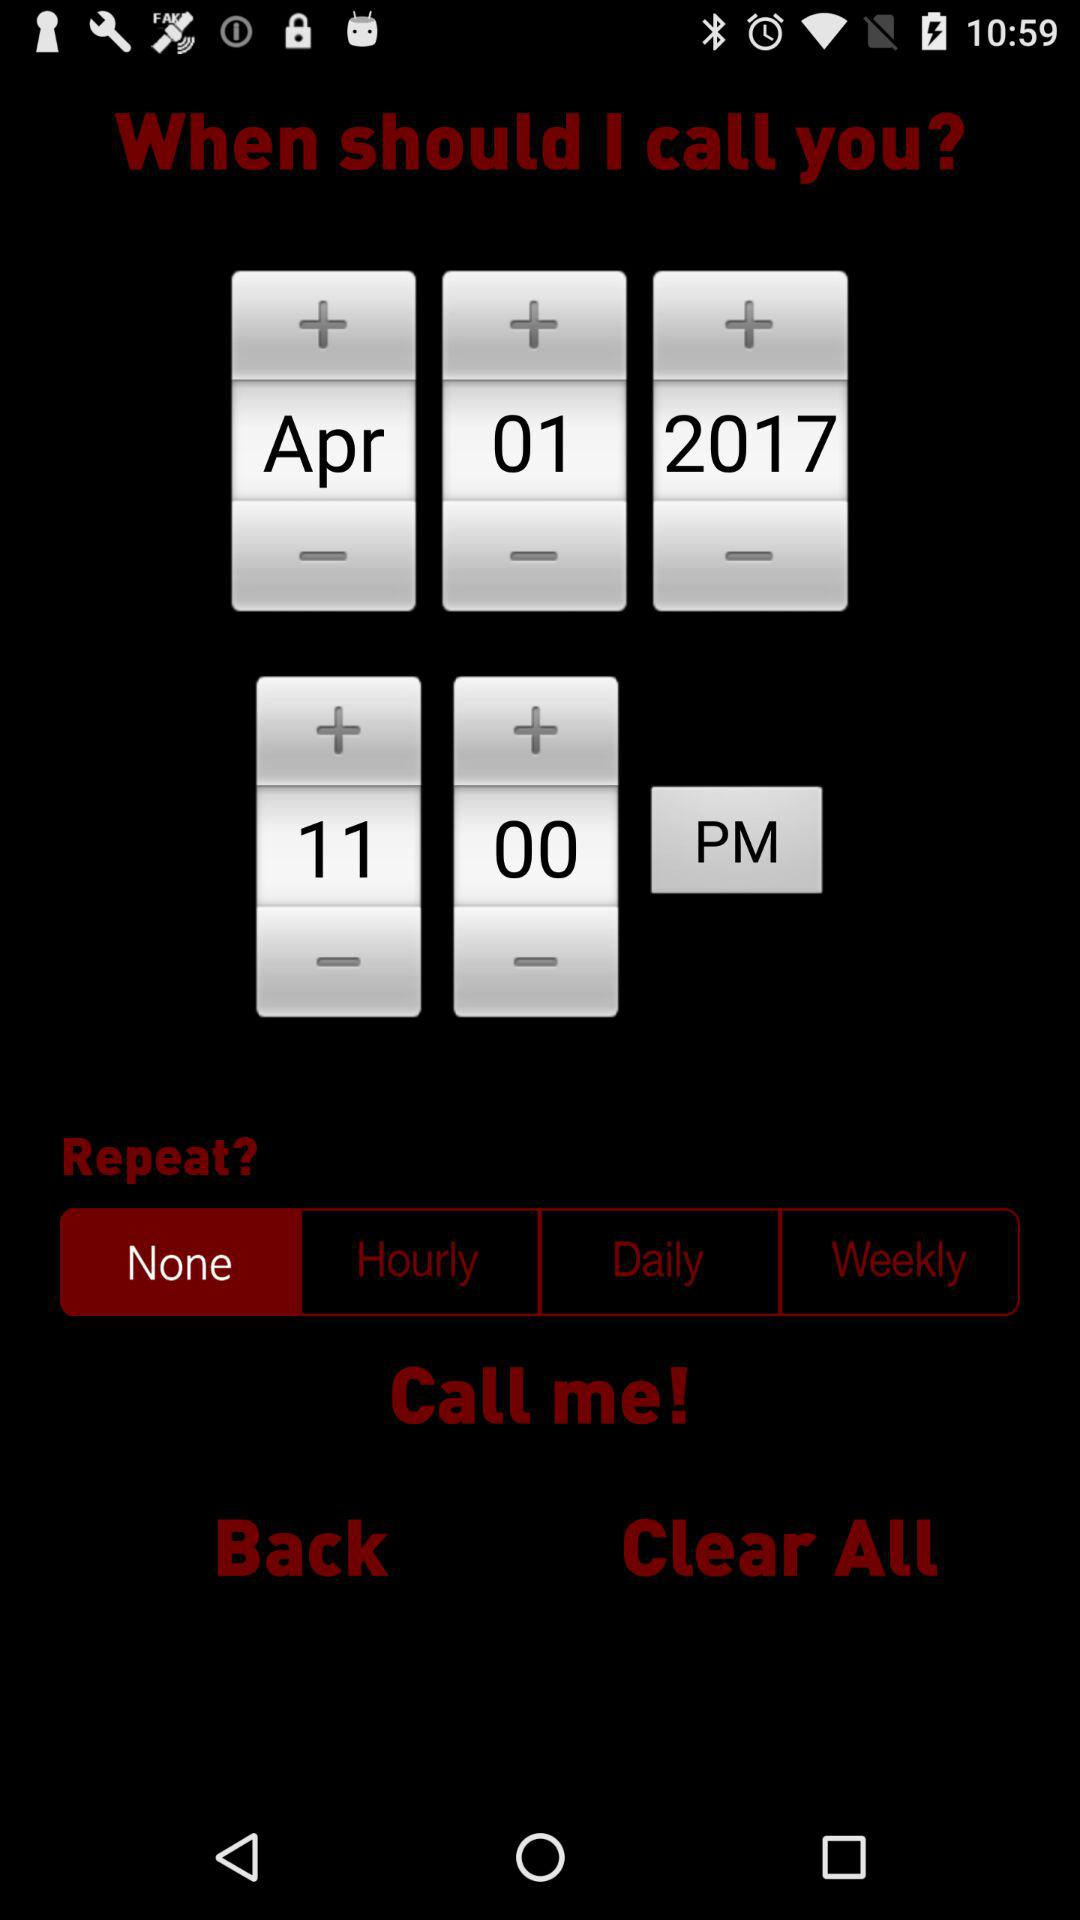What's the setting for the repeat? The setting for the repeat is "None". 